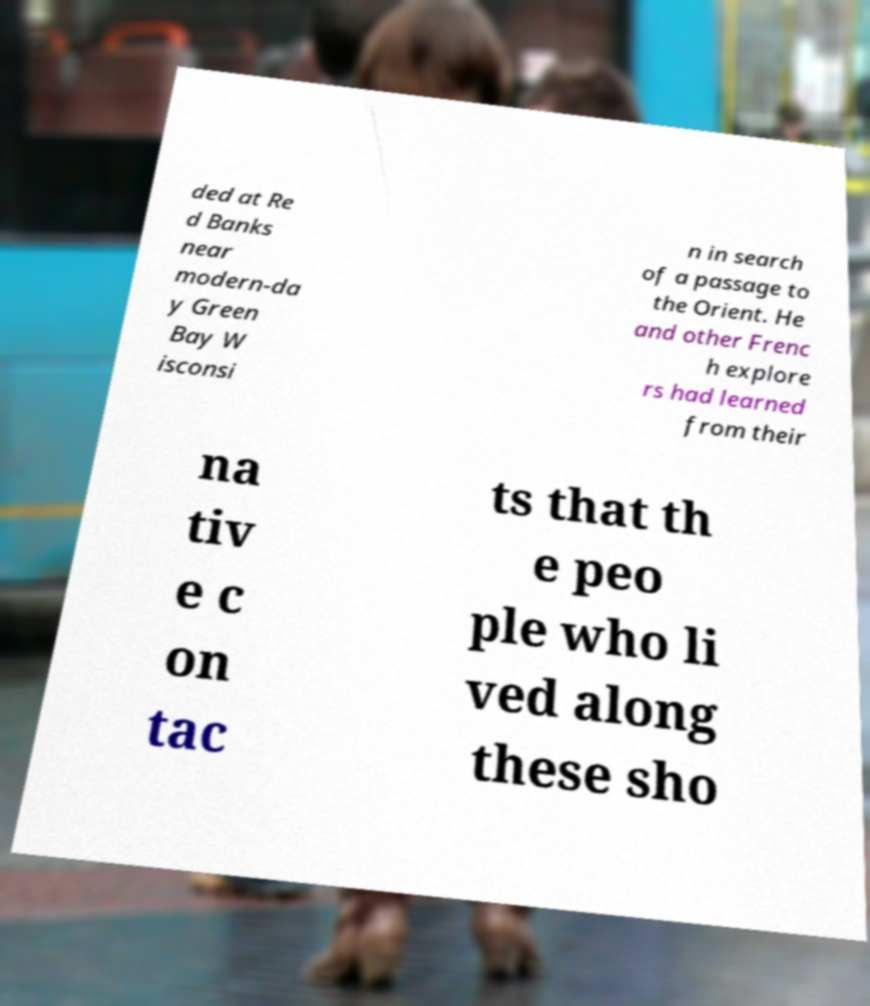There's text embedded in this image that I need extracted. Can you transcribe it verbatim? ded at Re d Banks near modern-da y Green Bay W isconsi n in search of a passage to the Orient. He and other Frenc h explore rs had learned from their na tiv e c on tac ts that th e peo ple who li ved along these sho 